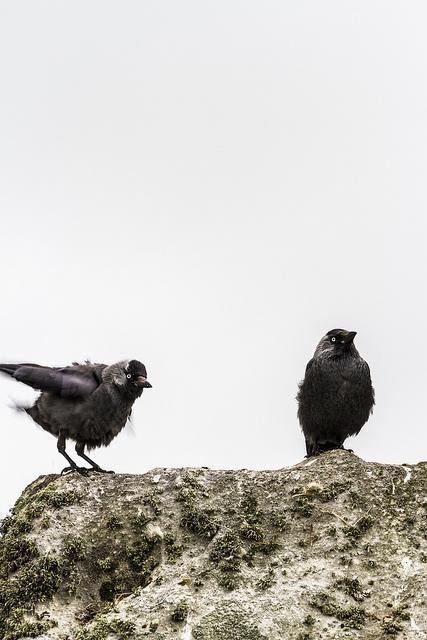How many birds are there?
Give a very brief answer. 2. 